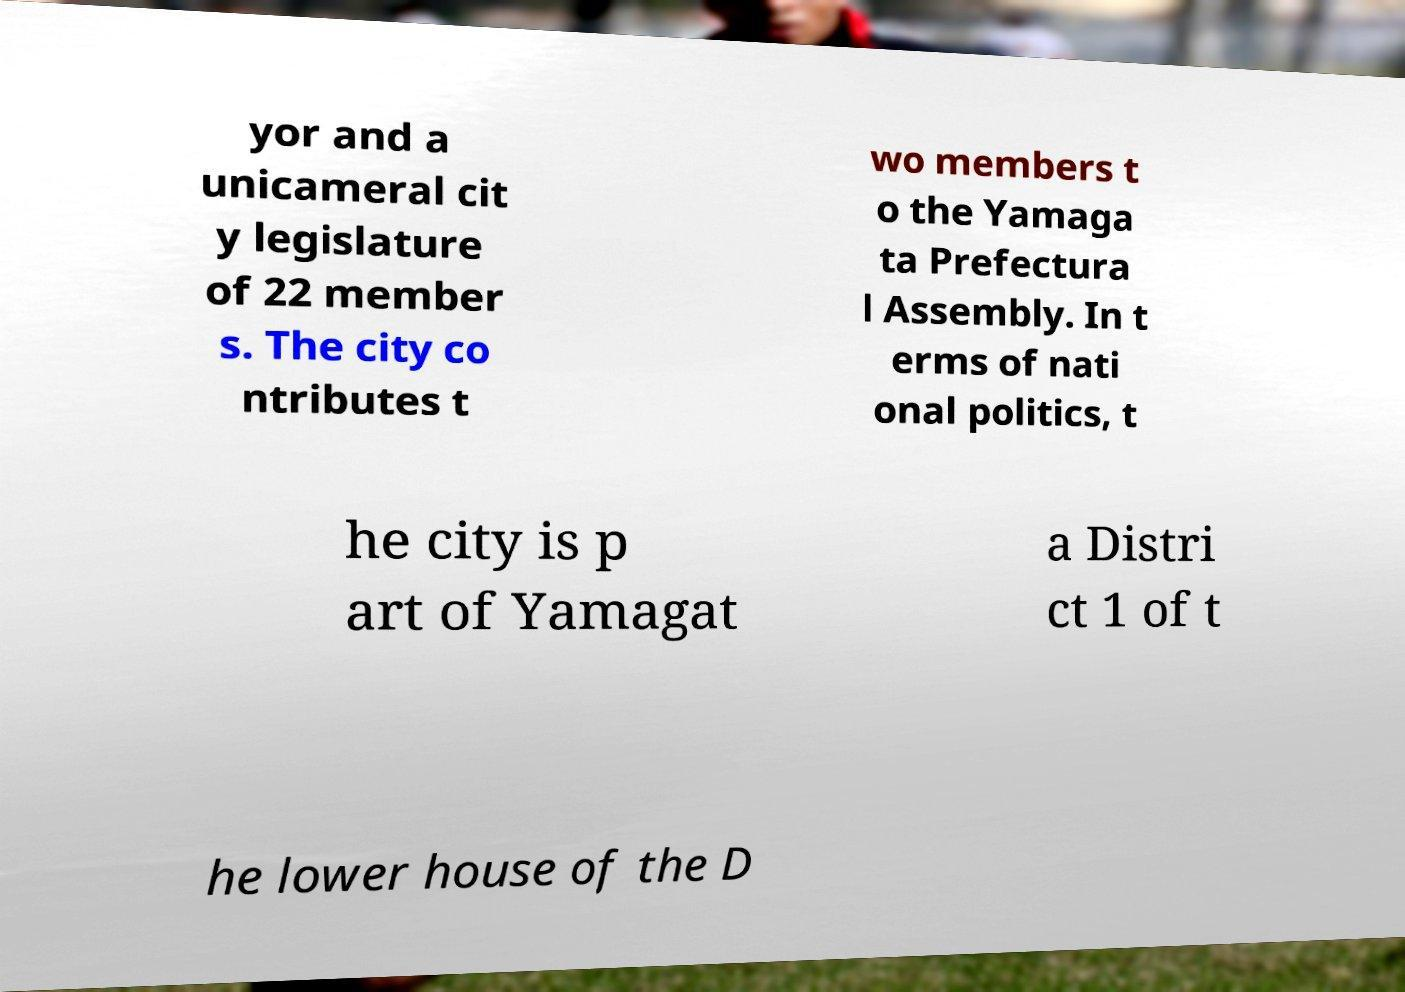There's text embedded in this image that I need extracted. Can you transcribe it verbatim? yor and a unicameral cit y legislature of 22 member s. The city co ntributes t wo members t o the Yamaga ta Prefectura l Assembly. In t erms of nati onal politics, t he city is p art of Yamagat a Distri ct 1 of t he lower house of the D 